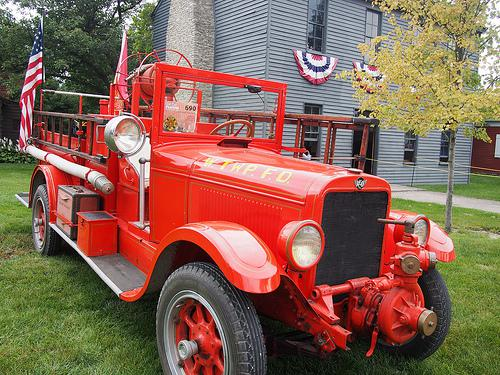Question: who is in the truck?
Choices:
A. The man going to work.
B. There is no one in the truck.
C. Mother and two children.
D. Teenage boy and his girlfriend.
Answer with the letter. Answer: B Question: where is the truck?
Choices:
A. In the drive way.
B. In the grass.
C. Stopped at a stop sign.
D. Next to the blue car.
Answer with the letter. Answer: B Question: what color is the truck?
Choices:
A. Red.
B. Green.
C. Blue.
D. Black.
Answer with the letter. Answer: A 